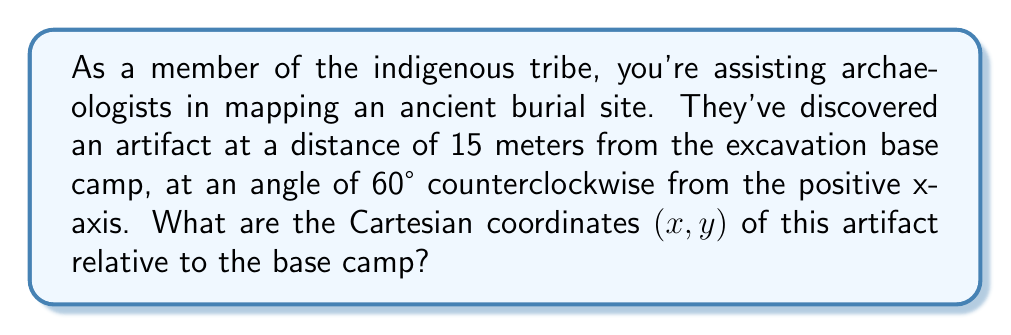Can you solve this math problem? To solve this problem, we need to convert the given polar coordinates to Cartesian coordinates. Let's approach this step-by-step:

1) In polar coordinates, we have:
   $r = 15$ (distance from the origin)
   $\theta = 60°$ (angle from the positive x-axis)

2) The formulas to convert from polar to Cartesian coordinates are:
   $x = r \cos(\theta)$
   $y = r \sin(\theta)$

3) Let's calculate x:
   $x = 15 \cos(60°)$
   $\cos(60°) = \frac{1}{2}$
   So, $x = 15 \cdot \frac{1}{2} = 7.5$

4) Now, let's calculate y:
   $y = 15 \sin(60°)$
   $\sin(60°) = \frac{\sqrt{3}}{2}$
   So, $y = 15 \cdot \frac{\sqrt{3}}{2} = 7.5\sqrt{3}$

5) Therefore, the Cartesian coordinates are $(7.5, 7.5\sqrt{3})$

[asy]
import geometry;

size(200);
dot((0,0),Fill(black));
label("Base Camp", (0,0), SW);
draw((-1,0)--(5,0), arrow=Arrow(TeXHead));
draw((0,-1)--(0,5), arrow=Arrow(TeXHead));
draw((0,0)--(3.75,6.495), arrow=Arrow(TeXHead));
dot((3.75,6.495),Fill(red));
label("Artifact", (3.75,6.495), NE);
label("15m", (1.875,3.2475), NW);
draw(arc((0,0),1,0,60), L=Label("60°", position=MidPoint));
[/asy]
Answer: $(7.5, 7.5\sqrt{3})$ 